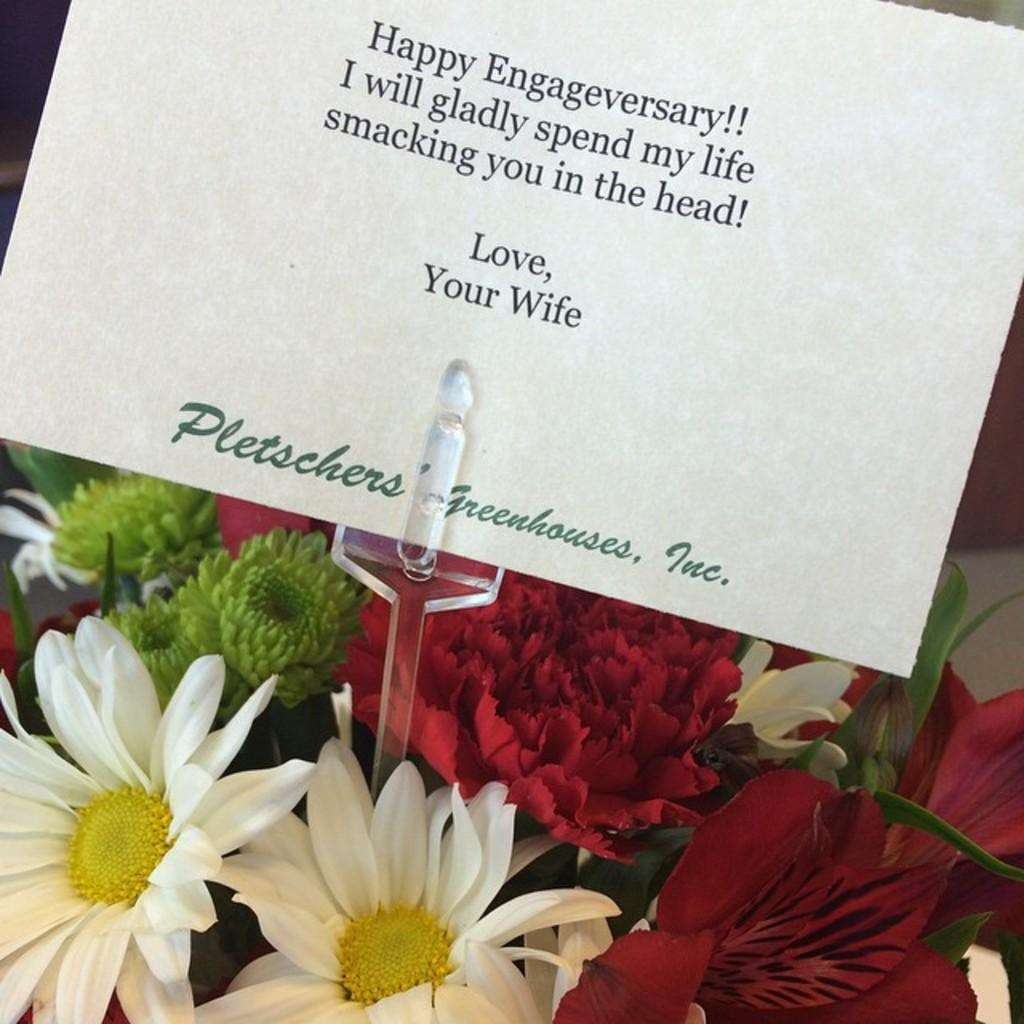What is featured on the poster in the image? There is a poster with text in the image. How is the poster displayed in the image? The poster is attached to a stand. What type of decorative elements can be seen at the bottom of the image? There are flowers in different colors at the bottom of the image. What connection does the writer have to the poster in the image? There is no writer mentioned or depicted in the image, so it is impossible to determine any connection. 